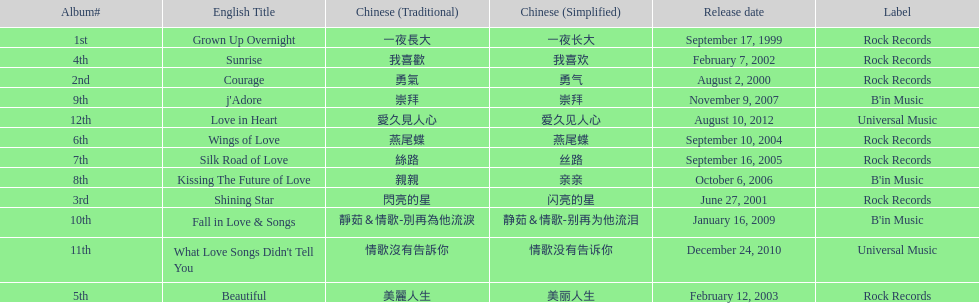Which song is listed first in the table? Grown Up Overnight. 